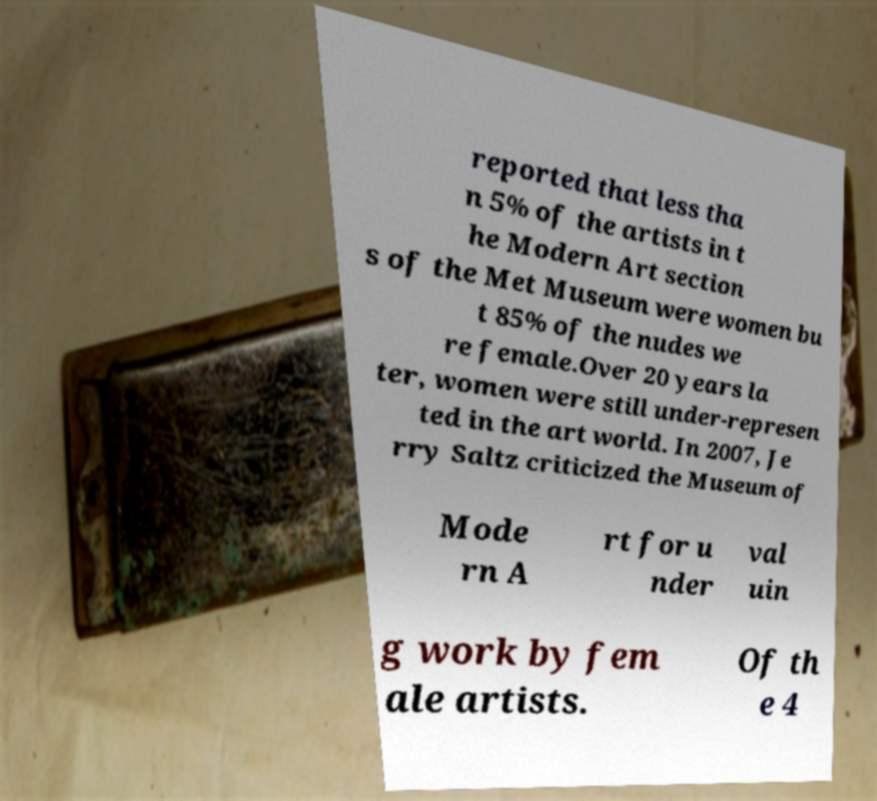Please identify and transcribe the text found in this image. reported that less tha n 5% of the artists in t he Modern Art section s of the Met Museum were women bu t 85% of the nudes we re female.Over 20 years la ter, women were still under-represen ted in the art world. In 2007, Je rry Saltz criticized the Museum of Mode rn A rt for u nder val uin g work by fem ale artists. Of th e 4 